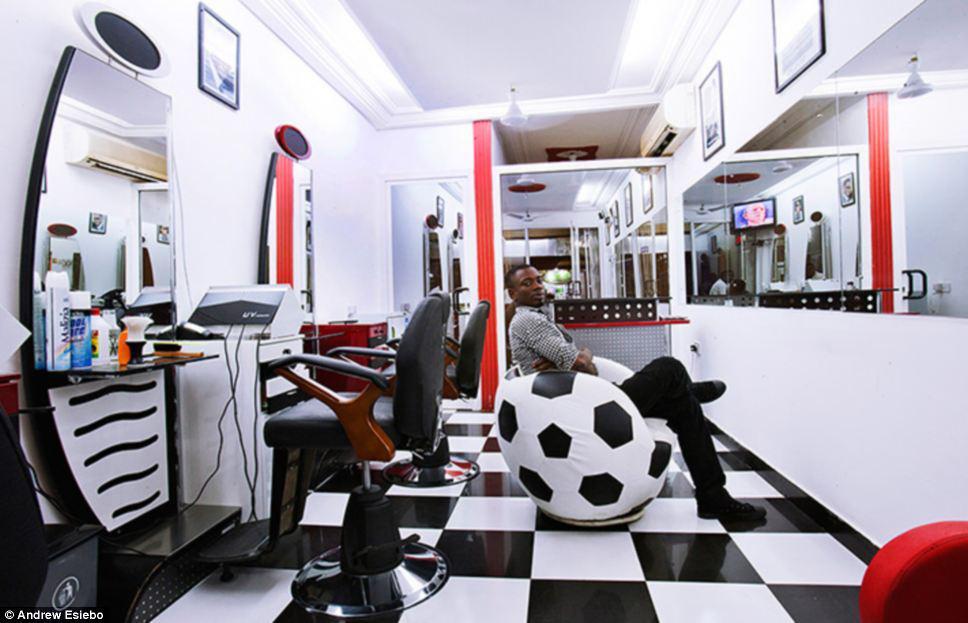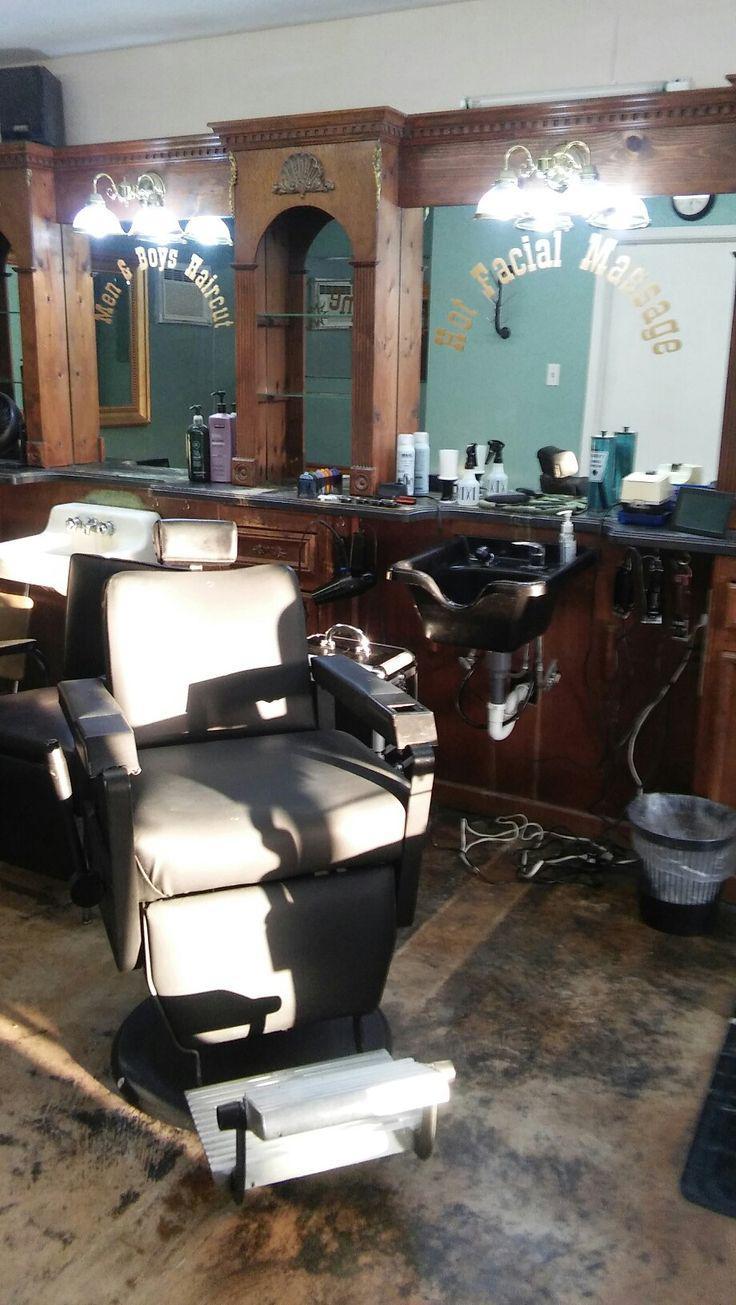The first image is the image on the left, the second image is the image on the right. Given the left and right images, does the statement "A barber is standing behind a client who is sitting." hold true? Answer yes or no. No. 